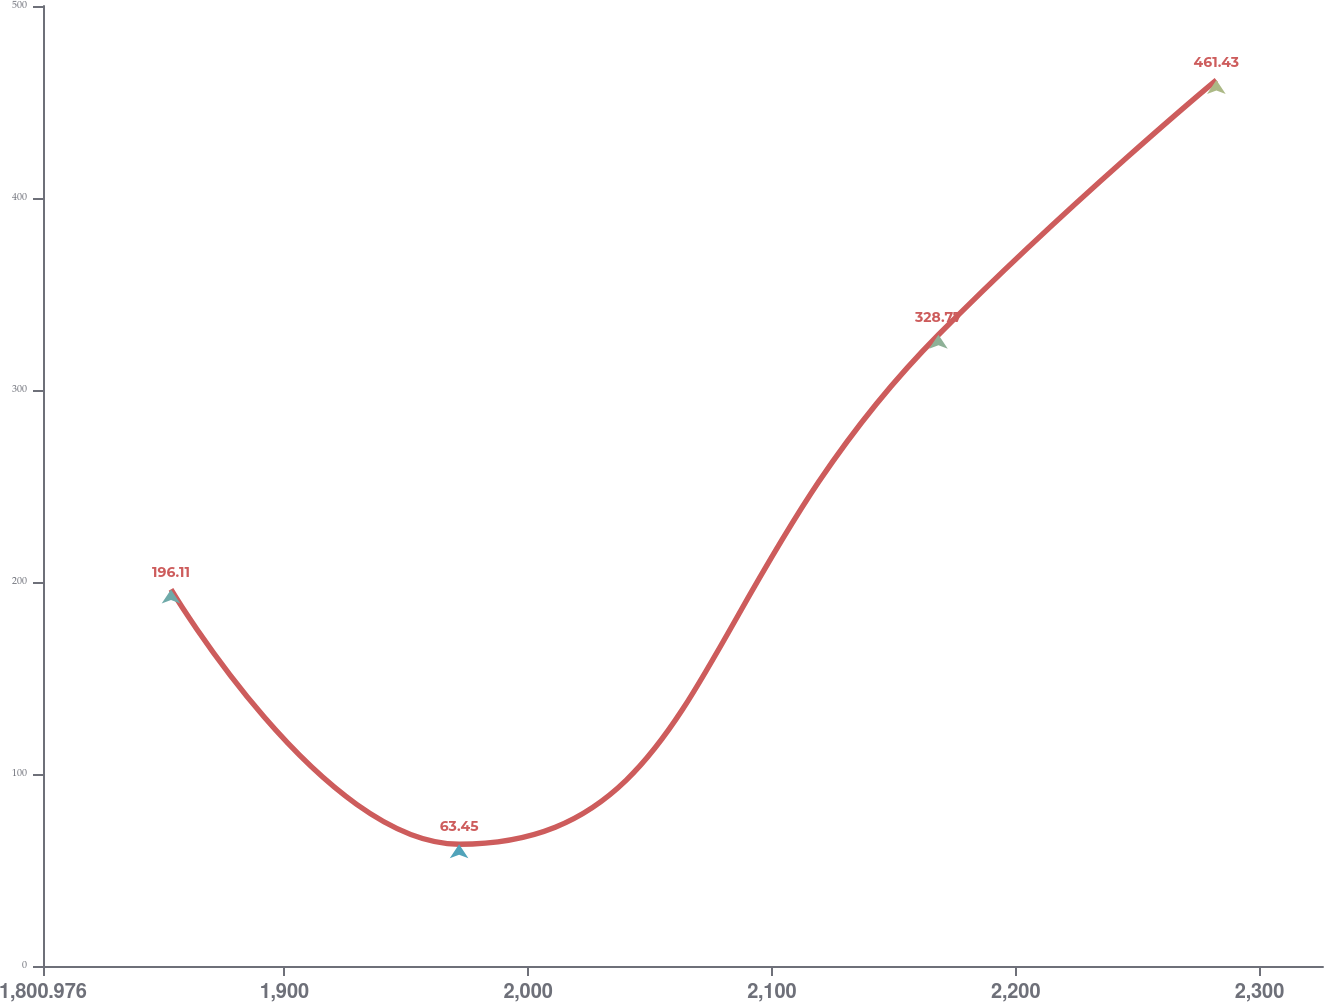Convert chart. <chart><loc_0><loc_0><loc_500><loc_500><line_chart><ecel><fcel>(Dollars in millions)<nl><fcel>1853.48<fcel>196.11<nl><fcel>1971.65<fcel>63.45<nl><fcel>2168.28<fcel>328.77<nl><fcel>2282.28<fcel>461.43<nl><fcel>2378.52<fcel>1390.09<nl></chart> 